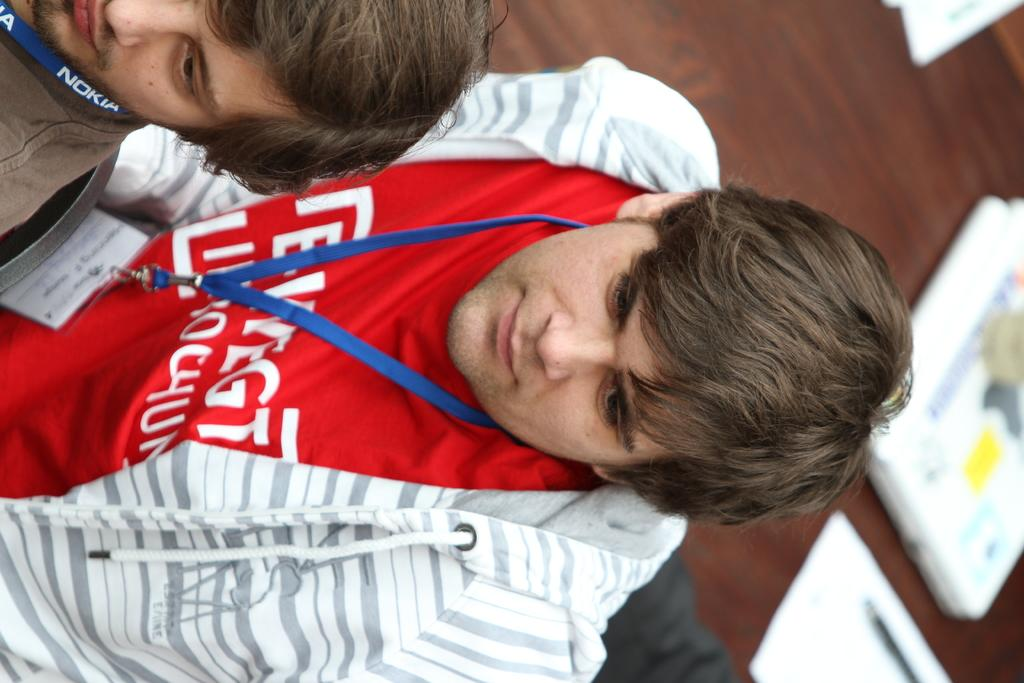<image>
Render a clear and concise summary of the photo. Two men wearing Nokia lanyards one of whom is wearing a red shirt. 